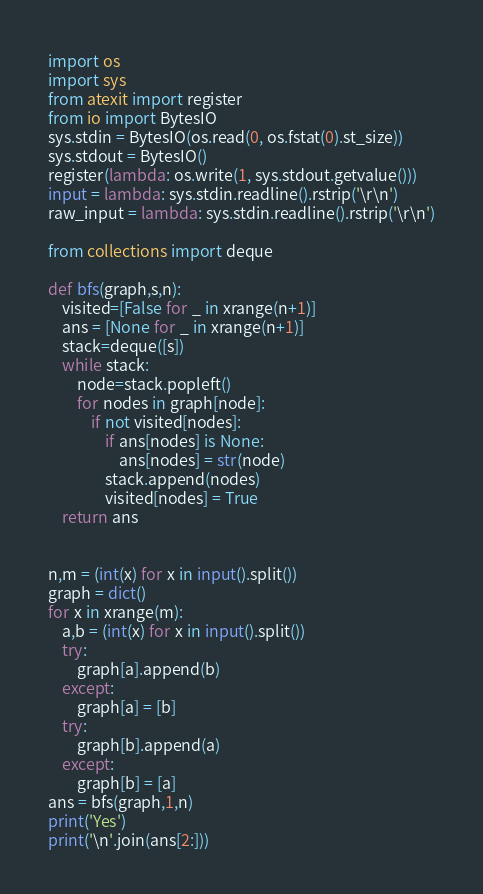Convert code to text. <code><loc_0><loc_0><loc_500><loc_500><_Python_>import os
import sys
from atexit import register
from io import BytesIO
sys.stdin = BytesIO(os.read(0, os.fstat(0).st_size))
sys.stdout = BytesIO()
register(lambda: os.write(1, sys.stdout.getvalue()))
input = lambda: sys.stdin.readline().rstrip('\r\n')
raw_input = lambda: sys.stdin.readline().rstrip('\r\n')

from collections import deque

def bfs(graph,s,n):
    visited=[False for _ in xrange(n+1)]
    ans = [None for _ in xrange(n+1)]
    stack=deque([s])
    while stack:
        node=stack.popleft()
        for nodes in graph[node]:
            if not visited[nodes]:
                if ans[nodes] is None:
                    ans[nodes] = str(node)
                stack.append(nodes)
                visited[nodes] = True
    return ans


n,m = (int(x) for x in input().split())
graph = dict()
for x in xrange(m):
    a,b = (int(x) for x in input().split())
    try:
        graph[a].append(b)
    except:
        graph[a] = [b]
    try:
        graph[b].append(a)
    except:
        graph[b] = [a]
ans = bfs(graph,1,n)
print('Yes')
print('\n'.join(ans[2:]))
</code> 